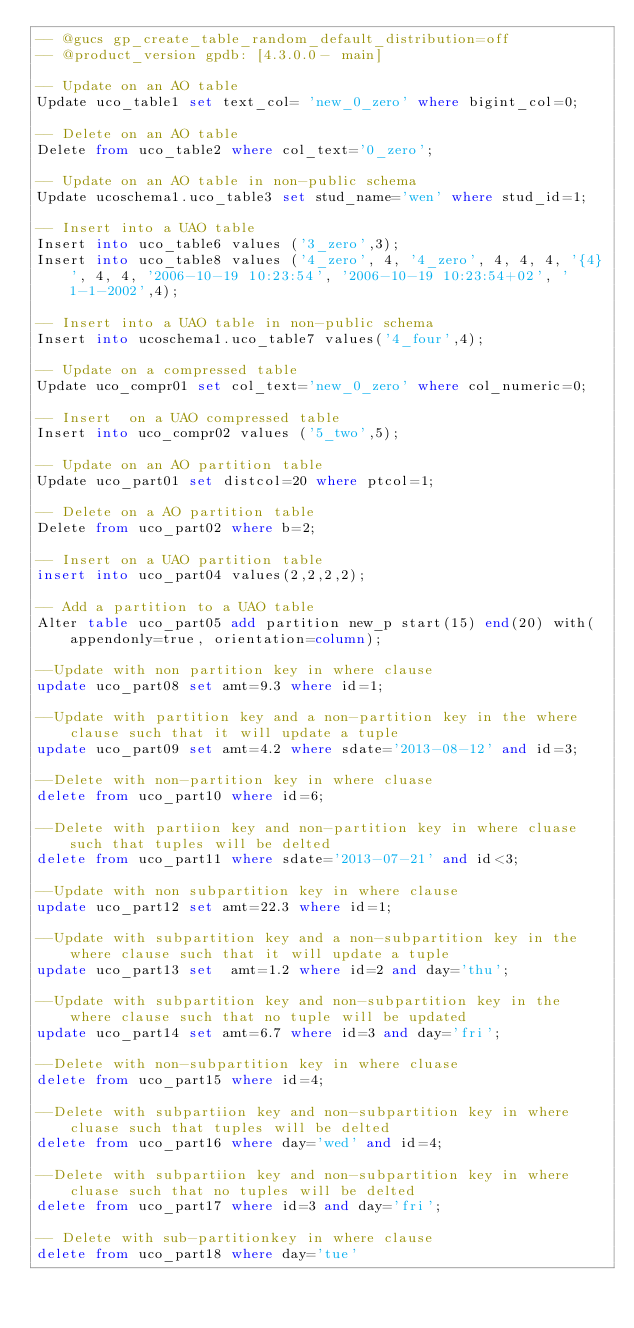<code> <loc_0><loc_0><loc_500><loc_500><_SQL_>-- @gucs gp_create_table_random_default_distribution=off
-- @product_version gpdb: [4.3.0.0- main]

-- Update on an AO table
Update uco_table1 set text_col= 'new_0_zero' where bigint_col=0;

-- Delete on an AO table
Delete from uco_table2 where col_text='0_zero';

-- Update on an AO table in non-public schema
Update ucoschema1.uco_table3 set stud_name='wen' where stud_id=1;

-- Insert into a UAO table
Insert into uco_table6 values ('3_zero',3);
Insert into uco_table8 values ('4_zero', 4, '4_zero', 4, 4, 4, '{4}', 4, 4, '2006-10-19 10:23:54', '2006-10-19 10:23:54+02', '1-1-2002',4);

-- Insert into a UAO table in non-public schema
Insert into ucoschema1.uco_table7 values('4_four',4);

-- Update on a compressed table
Update uco_compr01 set col_text='new_0_zero' where col_numeric=0;

-- Insert  on a UAO compressed table
Insert into uco_compr02 values ('5_two',5);

-- Update on an AO partition table
Update uco_part01 set distcol=20 where ptcol=1;

-- Delete on a AO partition table
Delete from uco_part02 where b=2;

-- Insert on a UAO partition table
insert into uco_part04 values(2,2,2,2);

-- Add a partition to a UAO table
Alter table uco_part05 add partition new_p start(15) end(20) with(appendonly=true, orientation=column);

--Update with non partition key in where clause
update uco_part08 set amt=9.3 where id=1;

--Update with partition key and a non-partition key in the where clause such that it will update a tuple 
update uco_part09 set amt=4.2 where sdate='2013-08-12' and id=3;

--Delete with non-partition key in where cluase
delete from uco_part10 where id=6;

--Delete with partiion key and non-partition key in where cluase such that tuples will be delted 
delete from uco_part11 where sdate='2013-07-21' and id<3;

--Update with non subpartition key in where clause
update uco_part12 set amt=22.3 where id=1;

--Update with subpartition key and a non-subpartition key in the where clause such that it will update a tuple 
update uco_part13 set  amt=1.2 where id=2 and day='thu';

--Update with subpartition key and non-subpartition key in the where clause such that no tuple will be updated 
update uco_part14 set amt=6.7 where id=3 and day='fri';

--Delete with non-subpartition key in where cluase 
delete from uco_part15 where id=4;

--Delete with subpartiion key and non-subpartition key in where cluase such that tuples will be delted 
delete from uco_part16 where day='wed' and id=4;

--Delete with subpartiion key and non-subpartition key in where cluase such that no tuples will be delted 
delete from uco_part17 where id=3 and day='fri';

-- Delete with sub-partitionkey in where clause
delete from uco_part18 where day='tue'
</code> 